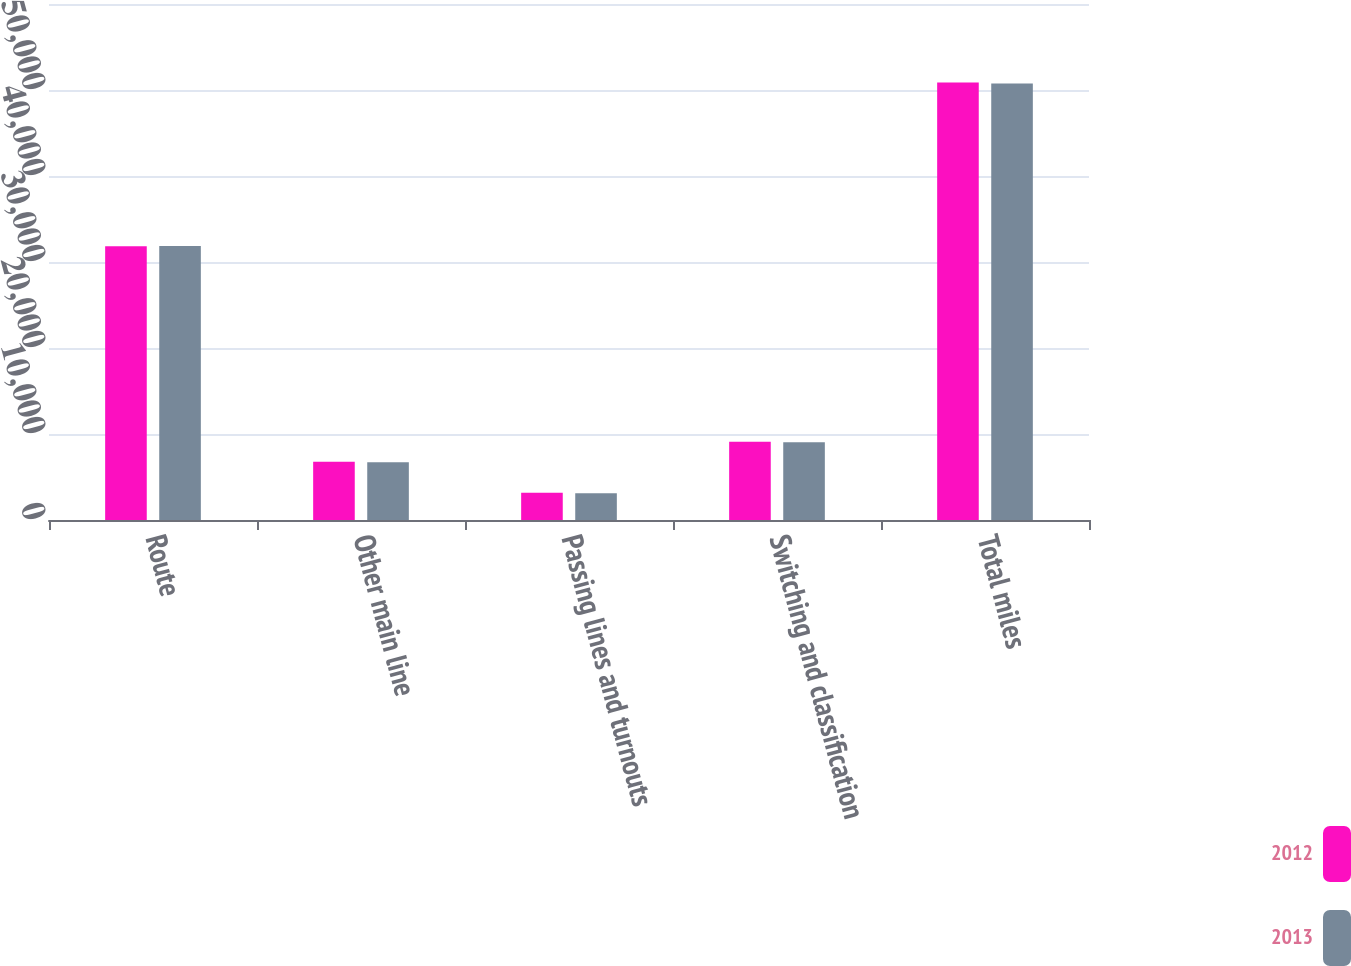Convert chart to OTSL. <chart><loc_0><loc_0><loc_500><loc_500><stacked_bar_chart><ecel><fcel>Route<fcel>Other main line<fcel>Passing lines and turnouts<fcel>Switching and classification<fcel>Total miles<nl><fcel>2012<fcel>31838<fcel>6766<fcel>3167<fcel>9090<fcel>50861<nl><fcel>2013<fcel>31868<fcel>6715<fcel>3124<fcel>9046<fcel>50753<nl></chart> 